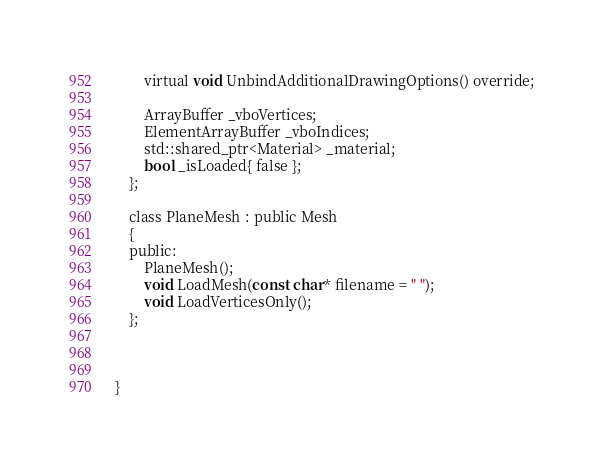<code> <loc_0><loc_0><loc_500><loc_500><_C_>		virtual void UnbindAdditionalDrawingOptions() override;

		ArrayBuffer _vboVertices;
		ElementArrayBuffer _vboIndices;
		std::shared_ptr<Material> _material;
		bool _isLoaded{ false };
	};

	class PlaneMesh : public Mesh
	{
	public:
		PlaneMesh();
		void LoadMesh(const char* filename = " ");
		void LoadVerticesOnly();
	};



}</code> 